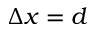Convert formula to latex. <formula><loc_0><loc_0><loc_500><loc_500>\Delta x = d</formula> 